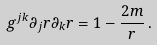<formula> <loc_0><loc_0><loc_500><loc_500>g ^ { j k } \partial _ { j } r \partial _ { k } r = 1 - \frac { 2 m } { r } \, .</formula> 